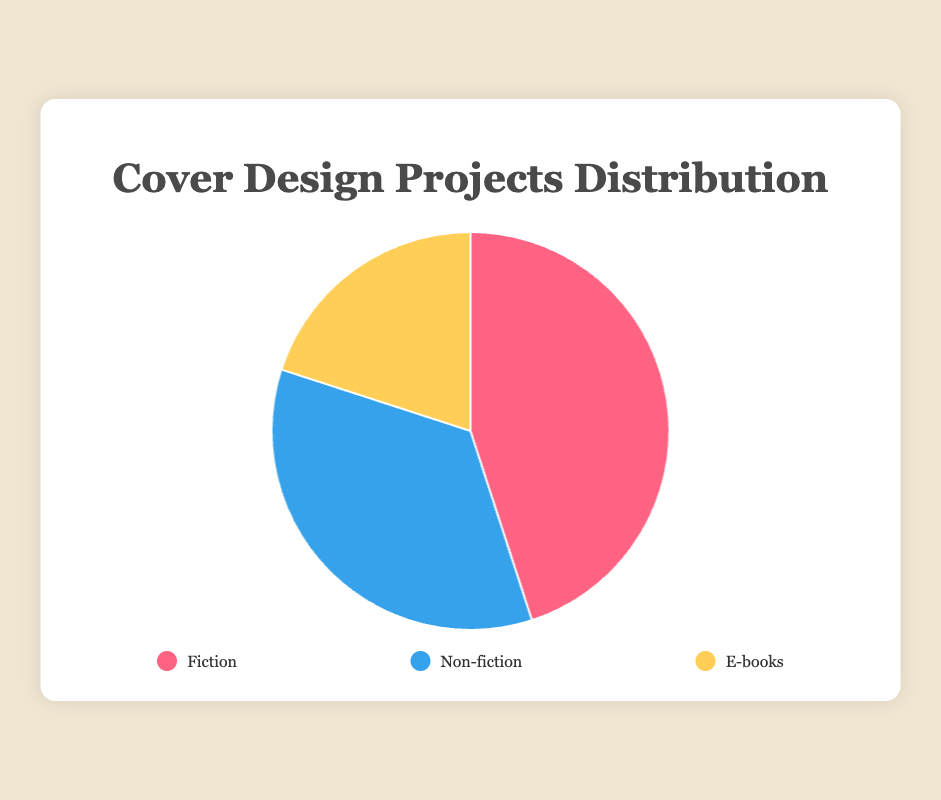What is the largest project type undertaken by freelance cover designers? The largest project type is represented by the largest portion of the pie chart. "Fiction" occupies 45% of the chart, which is the largest percentage.
Answer: Fiction Which project type has the smallest percentage? The smallest project type is represented by the smallest portion of the pie chart. "E-books" occupies 20% of the chart, which is the smallest percentage.
Answer: E-books How much larger is the percentage of Fiction projects compared to E-books projects? Fiction projects are 45% and E-books projects are 20%. The difference between them is 45% - 20% = 25%.
Answer: 25% What is the combined percentage of Fiction and Non-fiction projects? The percentage of Fiction projects is 45%, and Non-fiction projects is 35%. The combined percentage is 45% + 35% = 80%.
Answer: 80% How many times larger is the Fiction project percentage compared to the E-books project percentage? Fiction projects are 45% and E-books projects are 20%. To find how many times larger, divide 45% by 20%: 45 / 20 = 2.25.
Answer: 2.25 If the total number of projects is 100, how many of them are Non-fiction? Non-fiction projects make up 35% of the total. With a total of 100 projects, the number of Non-fiction projects is 35% of 100 = 35.
Answer: 35 Which two project types combined make up 65% of the total projects? Fiction is 45% and E-books is 20%. Combining these gives 45% + 20% = 65%.
Answer: Fiction and E-books What is the difference in percentage between the largest and smallest project type? The largest project type is Fiction with 45%, and the smallest is E-books with 20%. The difference is 45% - 20% = 25%.
Answer: 25% Which segment of the pie chart is shown in red? By visual inspection, the red segment corresponds to Fiction, which is 45% of the pie chart.
Answer: Fiction 